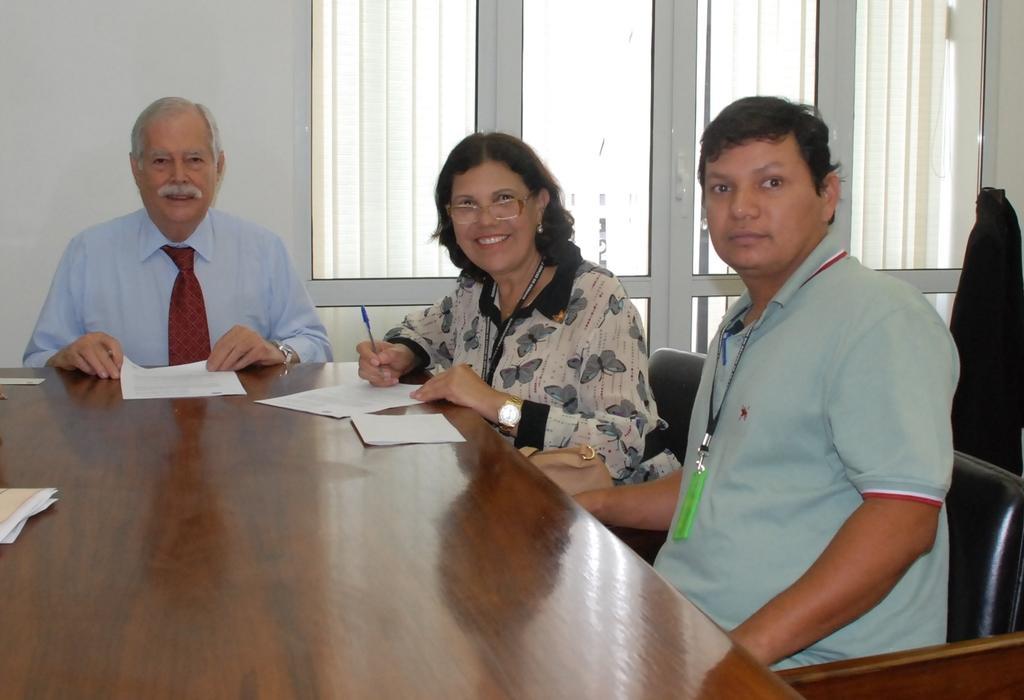How would you summarize this image in a sentence or two? This is a picture in a office. In this picture in the foreground there is a table on the table there are papers. On the left there is a man seated. In the center there is a woman seated and she is smiling. On the right there is a man seated in chair. In the background on the left there is wall. In the background at the center and the right there is a window. 